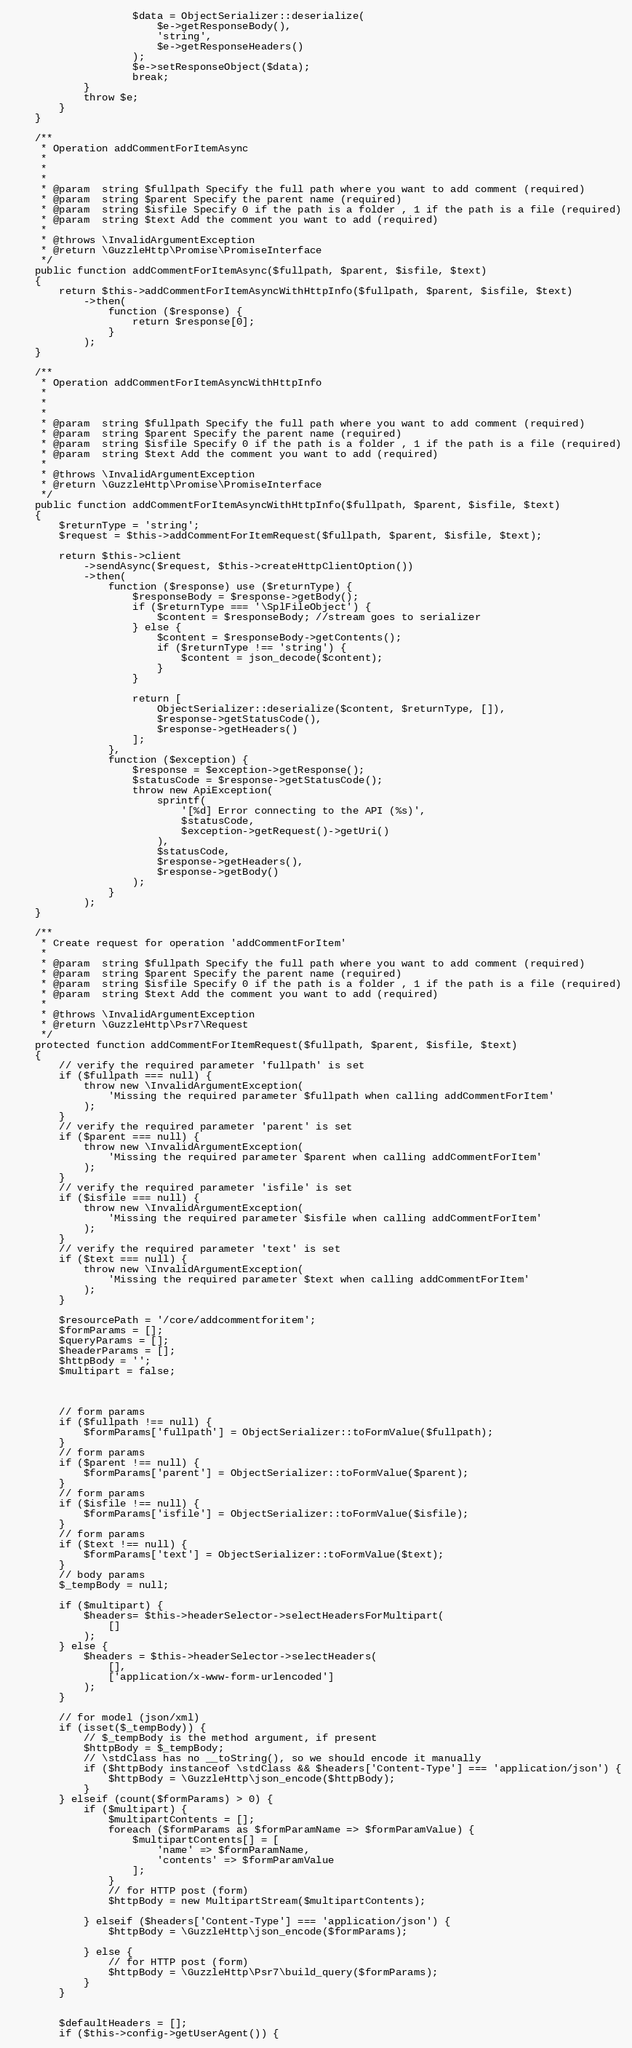Convert code to text. <code><loc_0><loc_0><loc_500><loc_500><_PHP_>                    $data = ObjectSerializer::deserialize(
                        $e->getResponseBody(),
                        'string',
                        $e->getResponseHeaders()
                    );
                    $e->setResponseObject($data);
                    break;
            }
            throw $e;
        }
    }

    /**
     * Operation addCommentForItemAsync
     *
     * 
     *
     * @param  string $fullpath Specify the full path where you want to add comment (required)
     * @param  string $parent Specify the parent name (required)
     * @param  string $isfile Specify 0 if the path is a folder , 1 if the path is a file (required)
     * @param  string $text Add the comment you want to add (required)
     *
     * @throws \InvalidArgumentException
     * @return \GuzzleHttp\Promise\PromiseInterface
     */
    public function addCommentForItemAsync($fullpath, $parent, $isfile, $text)
    {
        return $this->addCommentForItemAsyncWithHttpInfo($fullpath, $parent, $isfile, $text)
            ->then(
                function ($response) {
                    return $response[0];
                }
            );
    }

    /**
     * Operation addCommentForItemAsyncWithHttpInfo
     *
     * 
     *
     * @param  string $fullpath Specify the full path where you want to add comment (required)
     * @param  string $parent Specify the parent name (required)
     * @param  string $isfile Specify 0 if the path is a folder , 1 if the path is a file (required)
     * @param  string $text Add the comment you want to add (required)
     *
     * @throws \InvalidArgumentException
     * @return \GuzzleHttp\Promise\PromiseInterface
     */
    public function addCommentForItemAsyncWithHttpInfo($fullpath, $parent, $isfile, $text)
    {
        $returnType = 'string';
        $request = $this->addCommentForItemRequest($fullpath, $parent, $isfile, $text);

        return $this->client
            ->sendAsync($request, $this->createHttpClientOption())
            ->then(
                function ($response) use ($returnType) {
                    $responseBody = $response->getBody();
                    if ($returnType === '\SplFileObject') {
                        $content = $responseBody; //stream goes to serializer
                    } else {
                        $content = $responseBody->getContents();
                        if ($returnType !== 'string') {
                            $content = json_decode($content);
                        }
                    }

                    return [
                        ObjectSerializer::deserialize($content, $returnType, []),
                        $response->getStatusCode(),
                        $response->getHeaders()
                    ];
                },
                function ($exception) {
                    $response = $exception->getResponse();
                    $statusCode = $response->getStatusCode();
                    throw new ApiException(
                        sprintf(
                            '[%d] Error connecting to the API (%s)',
                            $statusCode,
                            $exception->getRequest()->getUri()
                        ),
                        $statusCode,
                        $response->getHeaders(),
                        $response->getBody()
                    );
                }
            );
    }

    /**
     * Create request for operation 'addCommentForItem'
     *
     * @param  string $fullpath Specify the full path where you want to add comment (required)
     * @param  string $parent Specify the parent name (required)
     * @param  string $isfile Specify 0 if the path is a folder , 1 if the path is a file (required)
     * @param  string $text Add the comment you want to add (required)
     *
     * @throws \InvalidArgumentException
     * @return \GuzzleHttp\Psr7\Request
     */
    protected function addCommentForItemRequest($fullpath, $parent, $isfile, $text)
    {
        // verify the required parameter 'fullpath' is set
        if ($fullpath === null) {
            throw new \InvalidArgumentException(
                'Missing the required parameter $fullpath when calling addCommentForItem'
            );
        }
        // verify the required parameter 'parent' is set
        if ($parent === null) {
            throw new \InvalidArgumentException(
                'Missing the required parameter $parent when calling addCommentForItem'
            );
        }
        // verify the required parameter 'isfile' is set
        if ($isfile === null) {
            throw new \InvalidArgumentException(
                'Missing the required parameter $isfile when calling addCommentForItem'
            );
        }
        // verify the required parameter 'text' is set
        if ($text === null) {
            throw new \InvalidArgumentException(
                'Missing the required parameter $text when calling addCommentForItem'
            );
        }

        $resourcePath = '/core/addcommentforitem';
        $formParams = [];
        $queryParams = [];
        $headerParams = [];
        $httpBody = '';
        $multipart = false;



        // form params
        if ($fullpath !== null) {
            $formParams['fullpath'] = ObjectSerializer::toFormValue($fullpath);
        }
        // form params
        if ($parent !== null) {
            $formParams['parent'] = ObjectSerializer::toFormValue($parent);
        }
        // form params
        if ($isfile !== null) {
            $formParams['isfile'] = ObjectSerializer::toFormValue($isfile);
        }
        // form params
        if ($text !== null) {
            $formParams['text'] = ObjectSerializer::toFormValue($text);
        }
        // body params
        $_tempBody = null;

        if ($multipart) {
            $headers= $this->headerSelector->selectHeadersForMultipart(
                []
            );
        } else {
            $headers = $this->headerSelector->selectHeaders(
                [],
                ['application/x-www-form-urlencoded']
            );
        }

        // for model (json/xml)
        if (isset($_tempBody)) {
            // $_tempBody is the method argument, if present
            $httpBody = $_tempBody;
            // \stdClass has no __toString(), so we should encode it manually
            if ($httpBody instanceof \stdClass && $headers['Content-Type'] === 'application/json') {
                $httpBody = \GuzzleHttp\json_encode($httpBody);
            }
        } elseif (count($formParams) > 0) {
            if ($multipart) {
                $multipartContents = [];
                foreach ($formParams as $formParamName => $formParamValue) {
                    $multipartContents[] = [
                        'name' => $formParamName,
                        'contents' => $formParamValue
                    ];
                }
                // for HTTP post (form)
                $httpBody = new MultipartStream($multipartContents);

            } elseif ($headers['Content-Type'] === 'application/json') {
                $httpBody = \GuzzleHttp\json_encode($formParams);

            } else {
                // for HTTP post (form)
                $httpBody = \GuzzleHttp\Psr7\build_query($formParams);
            }
        }


        $defaultHeaders = [];
        if ($this->config->getUserAgent()) {</code> 